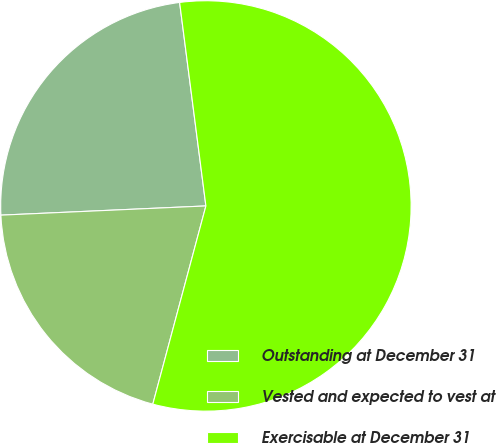Convert chart to OTSL. <chart><loc_0><loc_0><loc_500><loc_500><pie_chart><fcel>Outstanding at December 31<fcel>Vested and expected to vest at<fcel>Exercisable at December 31<nl><fcel>23.67%<fcel>20.12%<fcel>56.21%<nl></chart> 